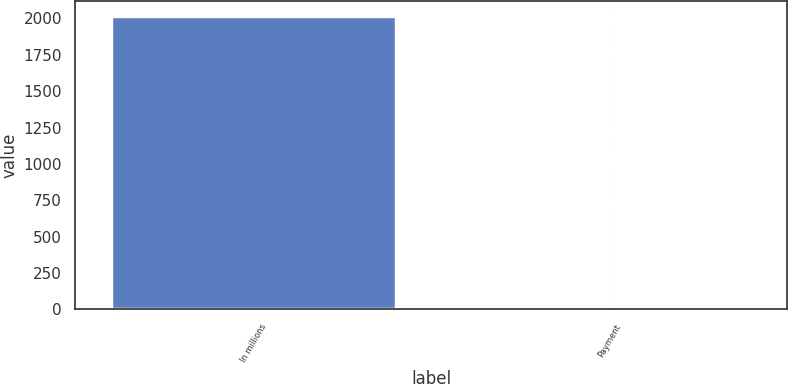<chart> <loc_0><loc_0><loc_500><loc_500><bar_chart><fcel>In millions<fcel>Payment<nl><fcel>2017<fcel>13<nl></chart> 